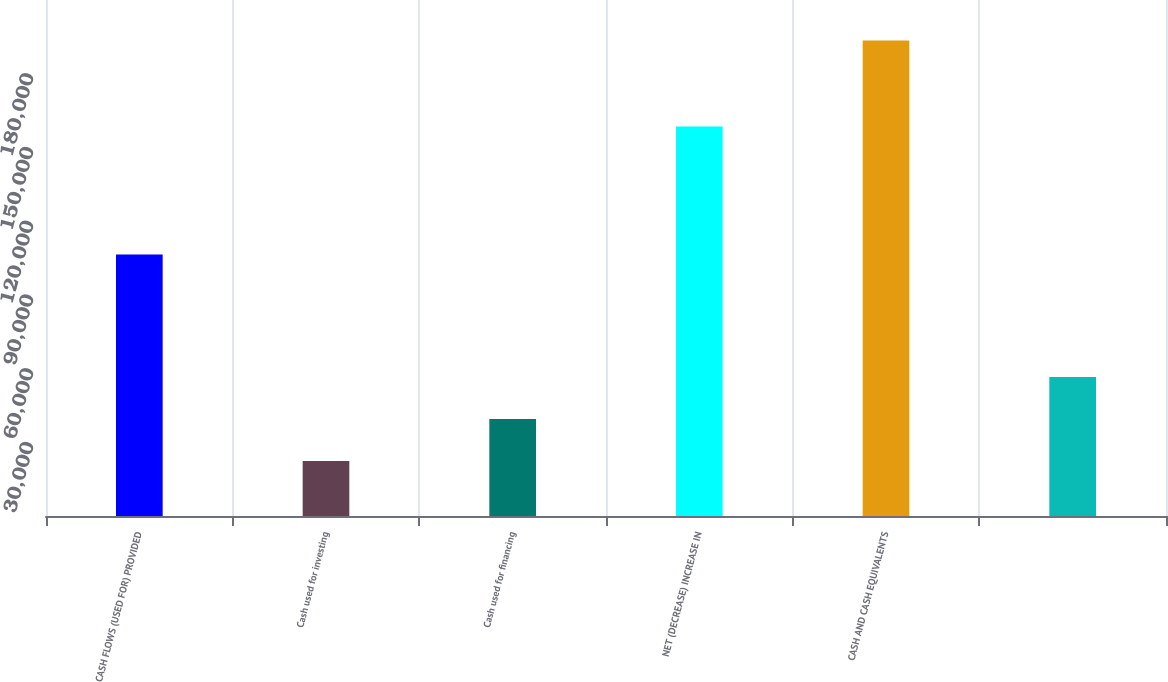Convert chart to OTSL. <chart><loc_0><loc_0><loc_500><loc_500><bar_chart><fcel>CASH FLOWS (USED FOR) PROVIDED<fcel>Cash used for investing<fcel>Cash used for financing<fcel>NET (DECREASE) INCREASE IN<fcel>CASH AND CASH EQUIVALENTS<fcel>Unnamed: 5<nl><fcel>106391<fcel>22349<fcel>39462.4<fcel>158473<fcel>193483<fcel>56575.8<nl></chart> 